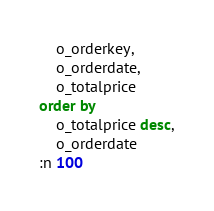Convert code to text. <code><loc_0><loc_0><loc_500><loc_500><_SQL_>	o_orderkey,
	o_orderdate,
	o_totalprice
order by
	o_totalprice desc,
	o_orderdate
:n 100
</code> 